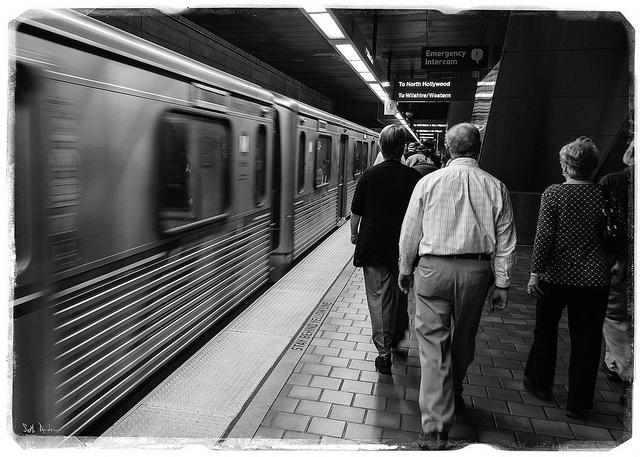What must be paid to ride this machine?

Choices:
A) fee
B) tax
C) donation
D) fare fare 